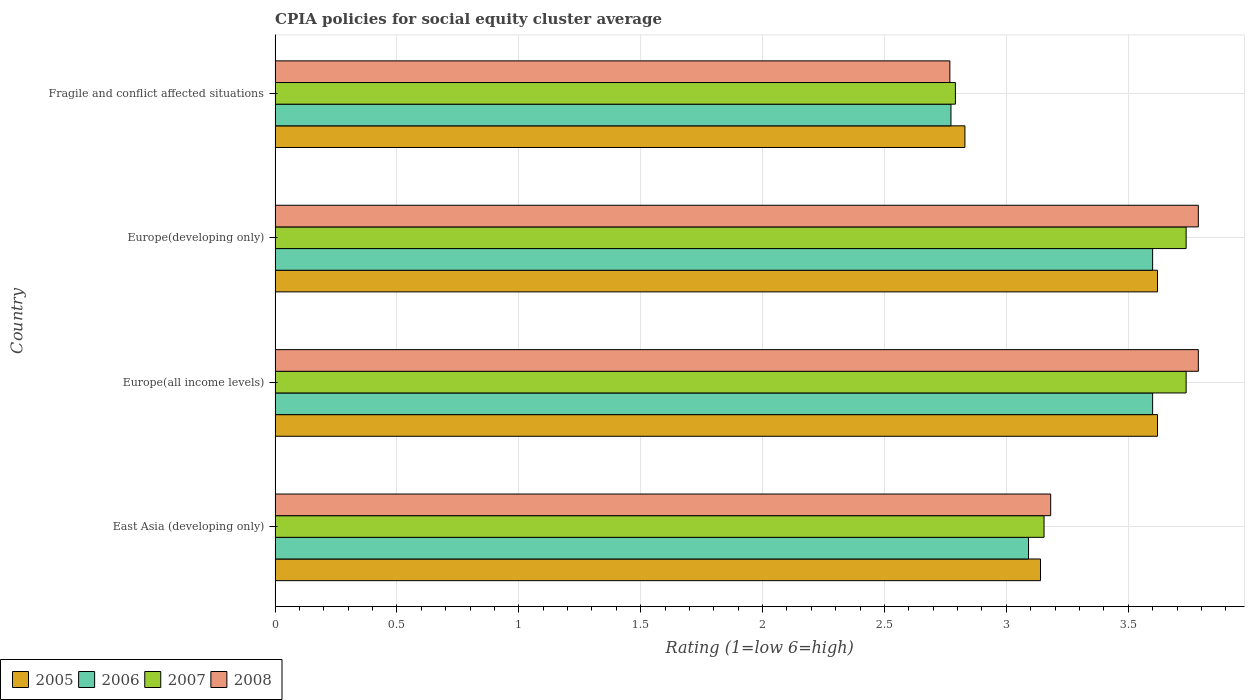How many different coloured bars are there?
Ensure brevity in your answer.  4. How many groups of bars are there?
Offer a terse response. 4. What is the label of the 4th group of bars from the top?
Your answer should be compact. East Asia (developing only). In how many cases, is the number of bars for a given country not equal to the number of legend labels?
Keep it short and to the point. 0. What is the CPIA rating in 2007 in Europe(developing only)?
Keep it short and to the point. 3.74. Across all countries, what is the maximum CPIA rating in 2007?
Offer a very short reply. 3.74. Across all countries, what is the minimum CPIA rating in 2006?
Your answer should be compact. 2.77. In which country was the CPIA rating in 2006 maximum?
Offer a very short reply. Europe(all income levels). In which country was the CPIA rating in 2006 minimum?
Offer a very short reply. Fragile and conflict affected situations. What is the total CPIA rating in 2008 in the graph?
Give a very brief answer. 13.52. What is the difference between the CPIA rating in 2005 in East Asia (developing only) and that in Fragile and conflict affected situations?
Give a very brief answer. 0.31. What is the difference between the CPIA rating in 2008 in Europe(developing only) and the CPIA rating in 2006 in Europe(all income levels)?
Ensure brevity in your answer.  0.19. What is the average CPIA rating in 2005 per country?
Your answer should be compact. 3.3. What is the difference between the CPIA rating in 2007 and CPIA rating in 2005 in Europe(all income levels)?
Ensure brevity in your answer.  0.12. In how many countries, is the CPIA rating in 2005 greater than 1.1 ?
Provide a short and direct response. 4. What is the ratio of the CPIA rating in 2005 in East Asia (developing only) to that in Europe(developing only)?
Make the answer very short. 0.87. Is the CPIA rating in 2006 in Europe(all income levels) less than that in Europe(developing only)?
Ensure brevity in your answer.  No. What is the difference between the highest and the second highest CPIA rating in 2007?
Keep it short and to the point. 0. What is the difference between the highest and the lowest CPIA rating in 2005?
Keep it short and to the point. 0.79. In how many countries, is the CPIA rating in 2006 greater than the average CPIA rating in 2006 taken over all countries?
Your response must be concise. 2. Is the sum of the CPIA rating in 2008 in East Asia (developing only) and Fragile and conflict affected situations greater than the maximum CPIA rating in 2005 across all countries?
Your answer should be very brief. Yes. Is it the case that in every country, the sum of the CPIA rating in 2007 and CPIA rating in 2006 is greater than the CPIA rating in 2008?
Your answer should be very brief. Yes. How many countries are there in the graph?
Your answer should be very brief. 4. What is the title of the graph?
Offer a very short reply. CPIA policies for social equity cluster average. What is the label or title of the X-axis?
Ensure brevity in your answer.  Rating (1=low 6=high). What is the Rating (1=low 6=high) in 2005 in East Asia (developing only)?
Keep it short and to the point. 3.14. What is the Rating (1=low 6=high) of 2006 in East Asia (developing only)?
Your answer should be very brief. 3.09. What is the Rating (1=low 6=high) in 2007 in East Asia (developing only)?
Your answer should be very brief. 3.15. What is the Rating (1=low 6=high) in 2008 in East Asia (developing only)?
Keep it short and to the point. 3.18. What is the Rating (1=low 6=high) in 2005 in Europe(all income levels)?
Give a very brief answer. 3.62. What is the Rating (1=low 6=high) of 2006 in Europe(all income levels)?
Your response must be concise. 3.6. What is the Rating (1=low 6=high) in 2007 in Europe(all income levels)?
Give a very brief answer. 3.74. What is the Rating (1=low 6=high) in 2008 in Europe(all income levels)?
Offer a very short reply. 3.79. What is the Rating (1=low 6=high) of 2005 in Europe(developing only)?
Provide a short and direct response. 3.62. What is the Rating (1=low 6=high) of 2006 in Europe(developing only)?
Your answer should be very brief. 3.6. What is the Rating (1=low 6=high) in 2007 in Europe(developing only)?
Make the answer very short. 3.74. What is the Rating (1=low 6=high) in 2008 in Europe(developing only)?
Give a very brief answer. 3.79. What is the Rating (1=low 6=high) of 2005 in Fragile and conflict affected situations?
Make the answer very short. 2.83. What is the Rating (1=low 6=high) of 2006 in Fragile and conflict affected situations?
Your answer should be compact. 2.77. What is the Rating (1=low 6=high) of 2007 in Fragile and conflict affected situations?
Your answer should be very brief. 2.79. What is the Rating (1=low 6=high) of 2008 in Fragile and conflict affected situations?
Make the answer very short. 2.77. Across all countries, what is the maximum Rating (1=low 6=high) in 2005?
Provide a short and direct response. 3.62. Across all countries, what is the maximum Rating (1=low 6=high) in 2006?
Give a very brief answer. 3.6. Across all countries, what is the maximum Rating (1=low 6=high) in 2007?
Offer a terse response. 3.74. Across all countries, what is the maximum Rating (1=low 6=high) of 2008?
Ensure brevity in your answer.  3.79. Across all countries, what is the minimum Rating (1=low 6=high) in 2005?
Make the answer very short. 2.83. Across all countries, what is the minimum Rating (1=low 6=high) in 2006?
Ensure brevity in your answer.  2.77. Across all countries, what is the minimum Rating (1=low 6=high) in 2007?
Make the answer very short. 2.79. Across all countries, what is the minimum Rating (1=low 6=high) in 2008?
Ensure brevity in your answer.  2.77. What is the total Rating (1=low 6=high) in 2005 in the graph?
Your response must be concise. 13.21. What is the total Rating (1=low 6=high) in 2006 in the graph?
Offer a very short reply. 13.06. What is the total Rating (1=low 6=high) of 2007 in the graph?
Keep it short and to the point. 13.42. What is the total Rating (1=low 6=high) in 2008 in the graph?
Your response must be concise. 13.53. What is the difference between the Rating (1=low 6=high) in 2005 in East Asia (developing only) and that in Europe(all income levels)?
Provide a succinct answer. -0.48. What is the difference between the Rating (1=low 6=high) in 2006 in East Asia (developing only) and that in Europe(all income levels)?
Your answer should be very brief. -0.51. What is the difference between the Rating (1=low 6=high) in 2007 in East Asia (developing only) and that in Europe(all income levels)?
Keep it short and to the point. -0.58. What is the difference between the Rating (1=low 6=high) in 2008 in East Asia (developing only) and that in Europe(all income levels)?
Give a very brief answer. -0.61. What is the difference between the Rating (1=low 6=high) of 2005 in East Asia (developing only) and that in Europe(developing only)?
Give a very brief answer. -0.48. What is the difference between the Rating (1=low 6=high) in 2006 in East Asia (developing only) and that in Europe(developing only)?
Your answer should be very brief. -0.51. What is the difference between the Rating (1=low 6=high) of 2007 in East Asia (developing only) and that in Europe(developing only)?
Provide a short and direct response. -0.58. What is the difference between the Rating (1=low 6=high) in 2008 in East Asia (developing only) and that in Europe(developing only)?
Your answer should be very brief. -0.61. What is the difference between the Rating (1=low 6=high) of 2005 in East Asia (developing only) and that in Fragile and conflict affected situations?
Your answer should be very brief. 0.31. What is the difference between the Rating (1=low 6=high) in 2006 in East Asia (developing only) and that in Fragile and conflict affected situations?
Keep it short and to the point. 0.32. What is the difference between the Rating (1=low 6=high) in 2007 in East Asia (developing only) and that in Fragile and conflict affected situations?
Your answer should be compact. 0.36. What is the difference between the Rating (1=low 6=high) in 2008 in East Asia (developing only) and that in Fragile and conflict affected situations?
Your answer should be compact. 0.41. What is the difference between the Rating (1=low 6=high) in 2005 in Europe(all income levels) and that in Europe(developing only)?
Make the answer very short. 0. What is the difference between the Rating (1=low 6=high) in 2007 in Europe(all income levels) and that in Europe(developing only)?
Provide a short and direct response. 0. What is the difference between the Rating (1=low 6=high) of 2005 in Europe(all income levels) and that in Fragile and conflict affected situations?
Keep it short and to the point. 0.79. What is the difference between the Rating (1=low 6=high) in 2006 in Europe(all income levels) and that in Fragile and conflict affected situations?
Provide a succinct answer. 0.83. What is the difference between the Rating (1=low 6=high) in 2007 in Europe(all income levels) and that in Fragile and conflict affected situations?
Your answer should be compact. 0.95. What is the difference between the Rating (1=low 6=high) of 2008 in Europe(all income levels) and that in Fragile and conflict affected situations?
Keep it short and to the point. 1.02. What is the difference between the Rating (1=low 6=high) of 2005 in Europe(developing only) and that in Fragile and conflict affected situations?
Ensure brevity in your answer.  0.79. What is the difference between the Rating (1=low 6=high) of 2006 in Europe(developing only) and that in Fragile and conflict affected situations?
Ensure brevity in your answer.  0.83. What is the difference between the Rating (1=low 6=high) in 2007 in Europe(developing only) and that in Fragile and conflict affected situations?
Keep it short and to the point. 0.95. What is the difference between the Rating (1=low 6=high) in 2008 in Europe(developing only) and that in Fragile and conflict affected situations?
Give a very brief answer. 1.02. What is the difference between the Rating (1=low 6=high) of 2005 in East Asia (developing only) and the Rating (1=low 6=high) of 2006 in Europe(all income levels)?
Your response must be concise. -0.46. What is the difference between the Rating (1=low 6=high) of 2005 in East Asia (developing only) and the Rating (1=low 6=high) of 2007 in Europe(all income levels)?
Make the answer very short. -0.6. What is the difference between the Rating (1=low 6=high) in 2005 in East Asia (developing only) and the Rating (1=low 6=high) in 2008 in Europe(all income levels)?
Your response must be concise. -0.65. What is the difference between the Rating (1=low 6=high) of 2006 in East Asia (developing only) and the Rating (1=low 6=high) of 2007 in Europe(all income levels)?
Offer a terse response. -0.65. What is the difference between the Rating (1=low 6=high) in 2006 in East Asia (developing only) and the Rating (1=low 6=high) in 2008 in Europe(all income levels)?
Your answer should be compact. -0.7. What is the difference between the Rating (1=low 6=high) in 2007 in East Asia (developing only) and the Rating (1=low 6=high) in 2008 in Europe(all income levels)?
Keep it short and to the point. -0.63. What is the difference between the Rating (1=low 6=high) in 2005 in East Asia (developing only) and the Rating (1=low 6=high) in 2006 in Europe(developing only)?
Ensure brevity in your answer.  -0.46. What is the difference between the Rating (1=low 6=high) of 2005 in East Asia (developing only) and the Rating (1=low 6=high) of 2007 in Europe(developing only)?
Make the answer very short. -0.6. What is the difference between the Rating (1=low 6=high) of 2005 in East Asia (developing only) and the Rating (1=low 6=high) of 2008 in Europe(developing only)?
Your answer should be very brief. -0.65. What is the difference between the Rating (1=low 6=high) of 2006 in East Asia (developing only) and the Rating (1=low 6=high) of 2007 in Europe(developing only)?
Offer a terse response. -0.65. What is the difference between the Rating (1=low 6=high) in 2006 in East Asia (developing only) and the Rating (1=low 6=high) in 2008 in Europe(developing only)?
Your response must be concise. -0.7. What is the difference between the Rating (1=low 6=high) in 2007 in East Asia (developing only) and the Rating (1=low 6=high) in 2008 in Europe(developing only)?
Your response must be concise. -0.63. What is the difference between the Rating (1=low 6=high) in 2005 in East Asia (developing only) and the Rating (1=low 6=high) in 2006 in Fragile and conflict affected situations?
Your answer should be very brief. 0.37. What is the difference between the Rating (1=low 6=high) in 2005 in East Asia (developing only) and the Rating (1=low 6=high) in 2007 in Fragile and conflict affected situations?
Give a very brief answer. 0.35. What is the difference between the Rating (1=low 6=high) of 2005 in East Asia (developing only) and the Rating (1=low 6=high) of 2008 in Fragile and conflict affected situations?
Make the answer very short. 0.37. What is the difference between the Rating (1=low 6=high) of 2006 in East Asia (developing only) and the Rating (1=low 6=high) of 2007 in Fragile and conflict affected situations?
Give a very brief answer. 0.3. What is the difference between the Rating (1=low 6=high) of 2006 in East Asia (developing only) and the Rating (1=low 6=high) of 2008 in Fragile and conflict affected situations?
Your response must be concise. 0.32. What is the difference between the Rating (1=low 6=high) in 2007 in East Asia (developing only) and the Rating (1=low 6=high) in 2008 in Fragile and conflict affected situations?
Provide a short and direct response. 0.39. What is the difference between the Rating (1=low 6=high) of 2005 in Europe(all income levels) and the Rating (1=low 6=high) of 2006 in Europe(developing only)?
Your answer should be very brief. 0.02. What is the difference between the Rating (1=low 6=high) in 2005 in Europe(all income levels) and the Rating (1=low 6=high) in 2007 in Europe(developing only)?
Provide a succinct answer. -0.12. What is the difference between the Rating (1=low 6=high) of 2005 in Europe(all income levels) and the Rating (1=low 6=high) of 2008 in Europe(developing only)?
Offer a terse response. -0.17. What is the difference between the Rating (1=low 6=high) of 2006 in Europe(all income levels) and the Rating (1=low 6=high) of 2007 in Europe(developing only)?
Offer a very short reply. -0.14. What is the difference between the Rating (1=low 6=high) of 2006 in Europe(all income levels) and the Rating (1=low 6=high) of 2008 in Europe(developing only)?
Provide a succinct answer. -0.19. What is the difference between the Rating (1=low 6=high) of 2007 in Europe(all income levels) and the Rating (1=low 6=high) of 2008 in Europe(developing only)?
Make the answer very short. -0.05. What is the difference between the Rating (1=low 6=high) of 2005 in Europe(all income levels) and the Rating (1=low 6=high) of 2006 in Fragile and conflict affected situations?
Keep it short and to the point. 0.85. What is the difference between the Rating (1=low 6=high) of 2005 in Europe(all income levels) and the Rating (1=low 6=high) of 2007 in Fragile and conflict affected situations?
Your answer should be very brief. 0.83. What is the difference between the Rating (1=low 6=high) of 2005 in Europe(all income levels) and the Rating (1=low 6=high) of 2008 in Fragile and conflict affected situations?
Give a very brief answer. 0.85. What is the difference between the Rating (1=low 6=high) of 2006 in Europe(all income levels) and the Rating (1=low 6=high) of 2007 in Fragile and conflict affected situations?
Give a very brief answer. 0.81. What is the difference between the Rating (1=low 6=high) of 2006 in Europe(all income levels) and the Rating (1=low 6=high) of 2008 in Fragile and conflict affected situations?
Your answer should be compact. 0.83. What is the difference between the Rating (1=low 6=high) in 2007 in Europe(all income levels) and the Rating (1=low 6=high) in 2008 in Fragile and conflict affected situations?
Your response must be concise. 0.97. What is the difference between the Rating (1=low 6=high) of 2005 in Europe(developing only) and the Rating (1=low 6=high) of 2006 in Fragile and conflict affected situations?
Offer a very short reply. 0.85. What is the difference between the Rating (1=low 6=high) in 2005 in Europe(developing only) and the Rating (1=low 6=high) in 2007 in Fragile and conflict affected situations?
Keep it short and to the point. 0.83. What is the difference between the Rating (1=low 6=high) of 2005 in Europe(developing only) and the Rating (1=low 6=high) of 2008 in Fragile and conflict affected situations?
Keep it short and to the point. 0.85. What is the difference between the Rating (1=low 6=high) of 2006 in Europe(developing only) and the Rating (1=low 6=high) of 2007 in Fragile and conflict affected situations?
Offer a terse response. 0.81. What is the difference between the Rating (1=low 6=high) of 2006 in Europe(developing only) and the Rating (1=low 6=high) of 2008 in Fragile and conflict affected situations?
Provide a short and direct response. 0.83. What is the difference between the Rating (1=low 6=high) of 2007 in Europe(developing only) and the Rating (1=low 6=high) of 2008 in Fragile and conflict affected situations?
Your response must be concise. 0.97. What is the average Rating (1=low 6=high) in 2005 per country?
Provide a succinct answer. 3.3. What is the average Rating (1=low 6=high) of 2006 per country?
Your response must be concise. 3.27. What is the average Rating (1=low 6=high) in 2007 per country?
Your response must be concise. 3.36. What is the average Rating (1=low 6=high) of 2008 per country?
Give a very brief answer. 3.38. What is the difference between the Rating (1=low 6=high) of 2005 and Rating (1=low 6=high) of 2006 in East Asia (developing only)?
Make the answer very short. 0.05. What is the difference between the Rating (1=low 6=high) in 2005 and Rating (1=low 6=high) in 2007 in East Asia (developing only)?
Provide a succinct answer. -0.01. What is the difference between the Rating (1=low 6=high) of 2005 and Rating (1=low 6=high) of 2008 in East Asia (developing only)?
Keep it short and to the point. -0.04. What is the difference between the Rating (1=low 6=high) in 2006 and Rating (1=low 6=high) in 2007 in East Asia (developing only)?
Give a very brief answer. -0.06. What is the difference between the Rating (1=low 6=high) in 2006 and Rating (1=low 6=high) in 2008 in East Asia (developing only)?
Provide a short and direct response. -0.09. What is the difference between the Rating (1=low 6=high) of 2007 and Rating (1=low 6=high) of 2008 in East Asia (developing only)?
Make the answer very short. -0.03. What is the difference between the Rating (1=low 6=high) in 2005 and Rating (1=low 6=high) in 2007 in Europe(all income levels)?
Give a very brief answer. -0.12. What is the difference between the Rating (1=low 6=high) of 2005 and Rating (1=low 6=high) of 2008 in Europe(all income levels)?
Offer a terse response. -0.17. What is the difference between the Rating (1=low 6=high) in 2006 and Rating (1=low 6=high) in 2007 in Europe(all income levels)?
Ensure brevity in your answer.  -0.14. What is the difference between the Rating (1=low 6=high) in 2006 and Rating (1=low 6=high) in 2008 in Europe(all income levels)?
Give a very brief answer. -0.19. What is the difference between the Rating (1=low 6=high) of 2005 and Rating (1=low 6=high) of 2006 in Europe(developing only)?
Provide a short and direct response. 0.02. What is the difference between the Rating (1=low 6=high) in 2005 and Rating (1=low 6=high) in 2007 in Europe(developing only)?
Provide a short and direct response. -0.12. What is the difference between the Rating (1=low 6=high) of 2005 and Rating (1=low 6=high) of 2008 in Europe(developing only)?
Provide a short and direct response. -0.17. What is the difference between the Rating (1=low 6=high) in 2006 and Rating (1=low 6=high) in 2007 in Europe(developing only)?
Keep it short and to the point. -0.14. What is the difference between the Rating (1=low 6=high) in 2006 and Rating (1=low 6=high) in 2008 in Europe(developing only)?
Make the answer very short. -0.19. What is the difference between the Rating (1=low 6=high) in 2007 and Rating (1=low 6=high) in 2008 in Europe(developing only)?
Ensure brevity in your answer.  -0.05. What is the difference between the Rating (1=low 6=high) of 2005 and Rating (1=low 6=high) of 2006 in Fragile and conflict affected situations?
Your response must be concise. 0.06. What is the difference between the Rating (1=low 6=high) of 2005 and Rating (1=low 6=high) of 2007 in Fragile and conflict affected situations?
Offer a terse response. 0.04. What is the difference between the Rating (1=low 6=high) of 2005 and Rating (1=low 6=high) of 2008 in Fragile and conflict affected situations?
Offer a very short reply. 0.06. What is the difference between the Rating (1=low 6=high) of 2006 and Rating (1=low 6=high) of 2007 in Fragile and conflict affected situations?
Give a very brief answer. -0.02. What is the difference between the Rating (1=low 6=high) of 2006 and Rating (1=low 6=high) of 2008 in Fragile and conflict affected situations?
Your answer should be very brief. 0. What is the difference between the Rating (1=low 6=high) in 2007 and Rating (1=low 6=high) in 2008 in Fragile and conflict affected situations?
Provide a short and direct response. 0.02. What is the ratio of the Rating (1=low 6=high) in 2005 in East Asia (developing only) to that in Europe(all income levels)?
Your answer should be compact. 0.87. What is the ratio of the Rating (1=low 6=high) in 2006 in East Asia (developing only) to that in Europe(all income levels)?
Keep it short and to the point. 0.86. What is the ratio of the Rating (1=low 6=high) of 2007 in East Asia (developing only) to that in Europe(all income levels)?
Ensure brevity in your answer.  0.84. What is the ratio of the Rating (1=low 6=high) of 2008 in East Asia (developing only) to that in Europe(all income levels)?
Make the answer very short. 0.84. What is the ratio of the Rating (1=low 6=high) in 2005 in East Asia (developing only) to that in Europe(developing only)?
Ensure brevity in your answer.  0.87. What is the ratio of the Rating (1=low 6=high) of 2006 in East Asia (developing only) to that in Europe(developing only)?
Keep it short and to the point. 0.86. What is the ratio of the Rating (1=low 6=high) of 2007 in East Asia (developing only) to that in Europe(developing only)?
Provide a short and direct response. 0.84. What is the ratio of the Rating (1=low 6=high) in 2008 in East Asia (developing only) to that in Europe(developing only)?
Provide a short and direct response. 0.84. What is the ratio of the Rating (1=low 6=high) of 2005 in East Asia (developing only) to that in Fragile and conflict affected situations?
Ensure brevity in your answer.  1.11. What is the ratio of the Rating (1=low 6=high) in 2006 in East Asia (developing only) to that in Fragile and conflict affected situations?
Make the answer very short. 1.11. What is the ratio of the Rating (1=low 6=high) of 2007 in East Asia (developing only) to that in Fragile and conflict affected situations?
Offer a terse response. 1.13. What is the ratio of the Rating (1=low 6=high) in 2008 in East Asia (developing only) to that in Fragile and conflict affected situations?
Provide a short and direct response. 1.15. What is the ratio of the Rating (1=low 6=high) of 2005 in Europe(all income levels) to that in Europe(developing only)?
Keep it short and to the point. 1. What is the ratio of the Rating (1=low 6=high) of 2007 in Europe(all income levels) to that in Europe(developing only)?
Give a very brief answer. 1. What is the ratio of the Rating (1=low 6=high) in 2008 in Europe(all income levels) to that in Europe(developing only)?
Your response must be concise. 1. What is the ratio of the Rating (1=low 6=high) in 2005 in Europe(all income levels) to that in Fragile and conflict affected situations?
Give a very brief answer. 1.28. What is the ratio of the Rating (1=low 6=high) in 2006 in Europe(all income levels) to that in Fragile and conflict affected situations?
Your answer should be compact. 1.3. What is the ratio of the Rating (1=low 6=high) in 2007 in Europe(all income levels) to that in Fragile and conflict affected situations?
Give a very brief answer. 1.34. What is the ratio of the Rating (1=low 6=high) of 2008 in Europe(all income levels) to that in Fragile and conflict affected situations?
Offer a very short reply. 1.37. What is the ratio of the Rating (1=low 6=high) in 2005 in Europe(developing only) to that in Fragile and conflict affected situations?
Provide a short and direct response. 1.28. What is the ratio of the Rating (1=low 6=high) of 2006 in Europe(developing only) to that in Fragile and conflict affected situations?
Offer a terse response. 1.3. What is the ratio of the Rating (1=low 6=high) in 2007 in Europe(developing only) to that in Fragile and conflict affected situations?
Keep it short and to the point. 1.34. What is the ratio of the Rating (1=low 6=high) in 2008 in Europe(developing only) to that in Fragile and conflict affected situations?
Offer a terse response. 1.37. What is the difference between the highest and the second highest Rating (1=low 6=high) in 2005?
Your answer should be very brief. 0. What is the difference between the highest and the lowest Rating (1=low 6=high) in 2005?
Keep it short and to the point. 0.79. What is the difference between the highest and the lowest Rating (1=low 6=high) of 2006?
Make the answer very short. 0.83. What is the difference between the highest and the lowest Rating (1=low 6=high) of 2007?
Your answer should be very brief. 0.95. What is the difference between the highest and the lowest Rating (1=low 6=high) in 2008?
Your answer should be compact. 1.02. 